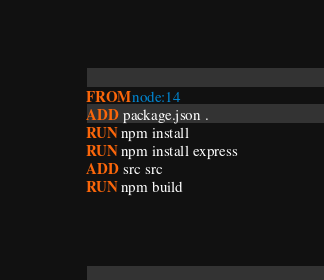Convert code to text. <code><loc_0><loc_0><loc_500><loc_500><_Dockerfile_>FROM node:14
ADD package.json .
RUN npm install
RUN npm install express
ADD src src
RUN npm build
</code> 